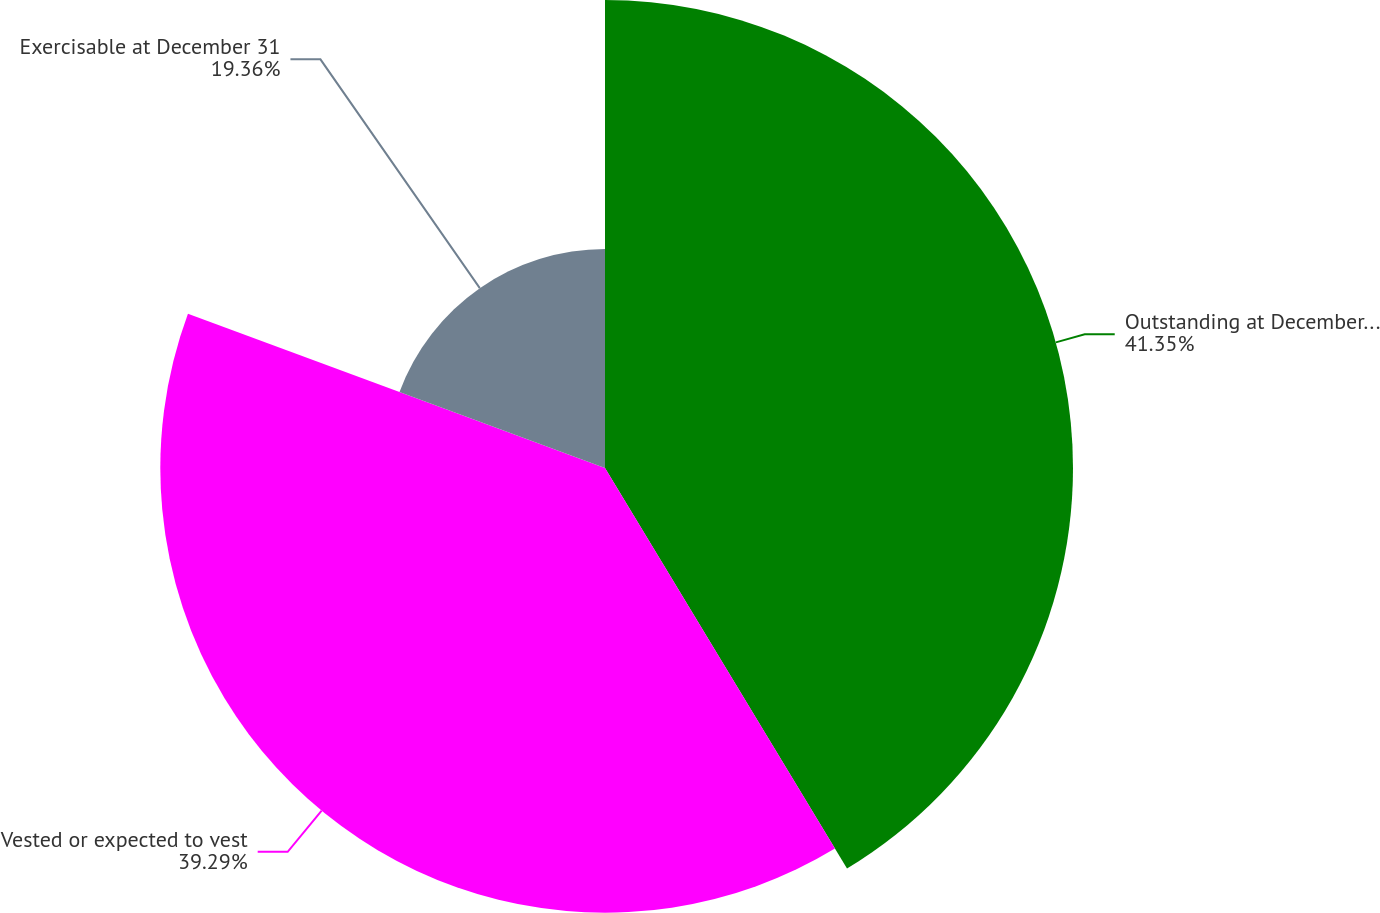<chart> <loc_0><loc_0><loc_500><loc_500><pie_chart><fcel>Outstanding at December 31<fcel>Vested or expected to vest<fcel>Exercisable at December 31<nl><fcel>41.35%<fcel>39.29%<fcel>19.36%<nl></chart> 